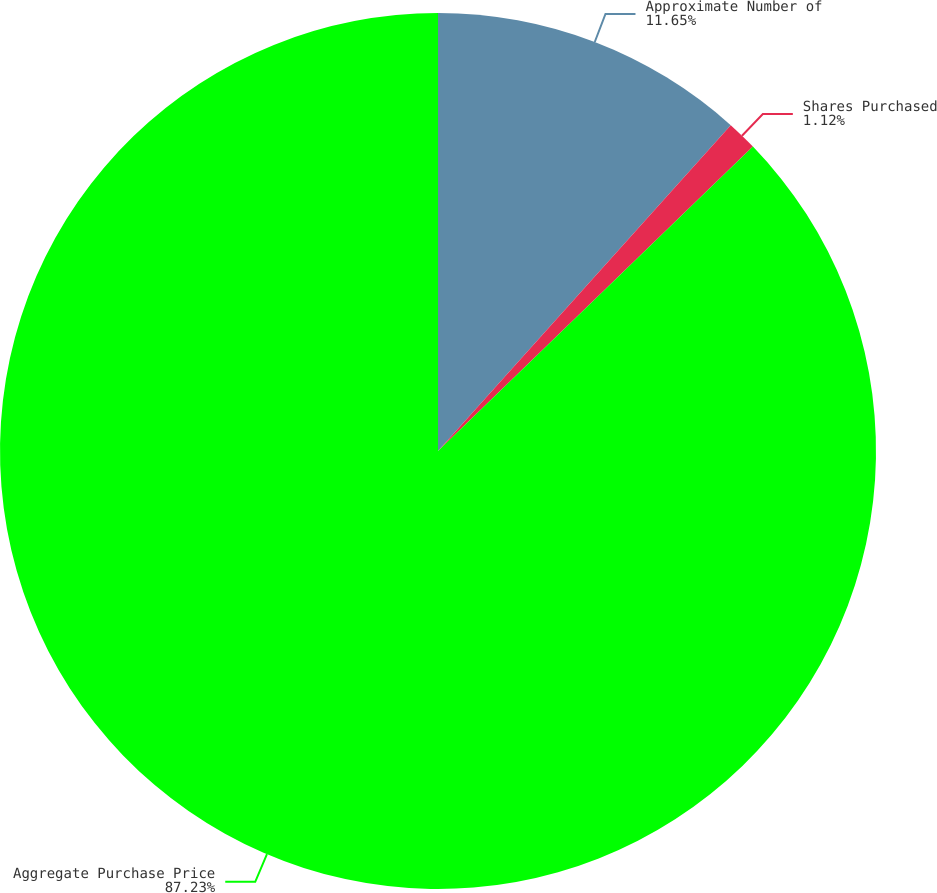Convert chart to OTSL. <chart><loc_0><loc_0><loc_500><loc_500><pie_chart><fcel>Approximate Number of<fcel>Shares Purchased<fcel>Aggregate Purchase Price<nl><fcel>11.65%<fcel>1.12%<fcel>87.23%<nl></chart> 